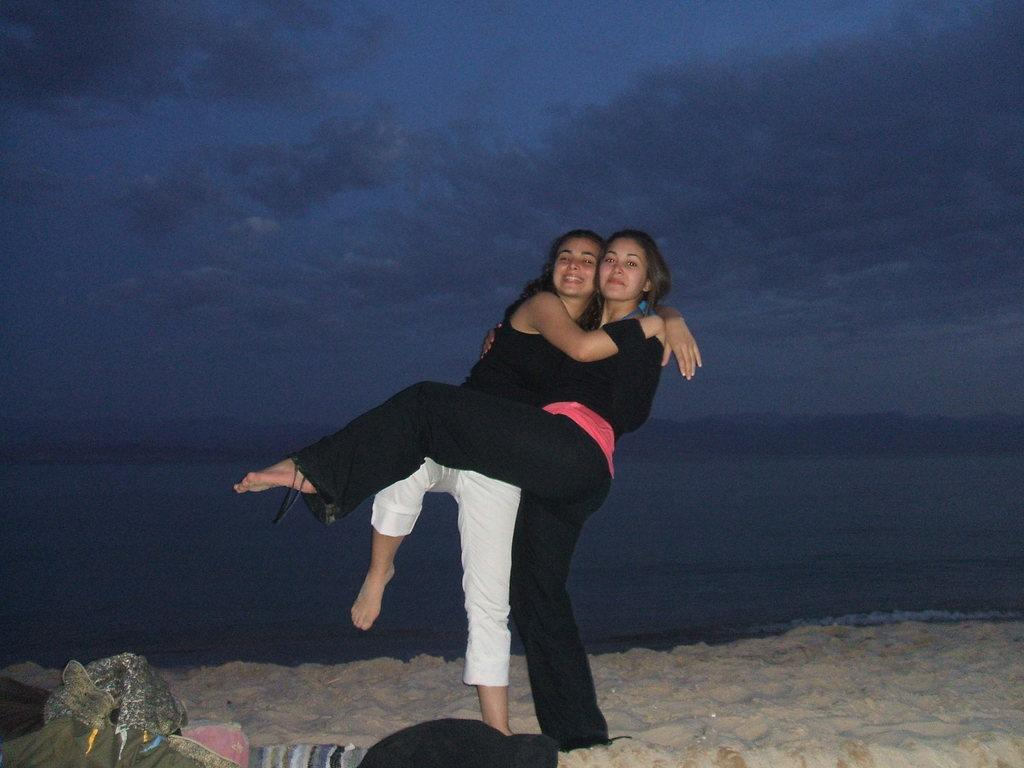How many people are in the image? There are two women in the image. What is the setting of the image? The women are on the sand, and there is water visible in the image. What can be seen in the background of the image? The sky is visible in the background of the image. What type of prison can be seen in the image? There is no prison present in the image; it features two women on the sand with water and sky visible in the background. How many potatoes are visible in the image? There are no potatoes present in the image. 